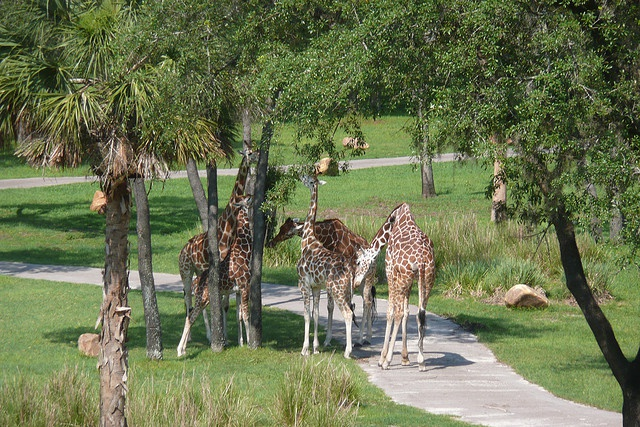Describe the objects in this image and their specific colors. I can see giraffe in black, lightgray, gray, darkgray, and tan tones, giraffe in black, gray, and maroon tones, giraffe in black, gray, darkgray, and lightgray tones, giraffe in black, gray, and maroon tones, and giraffe in black, gray, and darkgray tones in this image. 